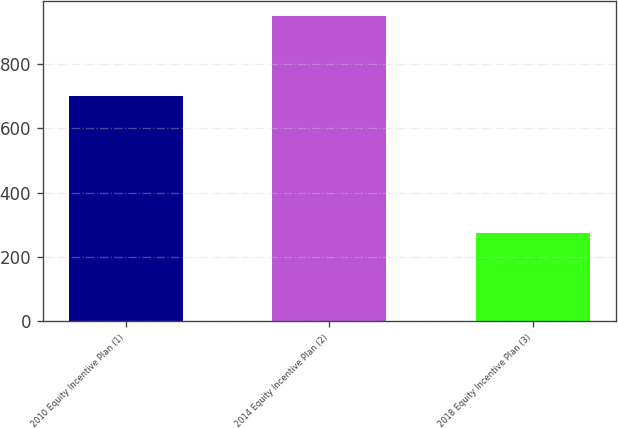<chart> <loc_0><loc_0><loc_500><loc_500><bar_chart><fcel>2010 Equity Incentive Plan (1)<fcel>2014 Equity Incentive Plan (2)<fcel>2018 Equity Incentive Plan (3)<nl><fcel>700<fcel>950<fcel>275<nl></chart> 